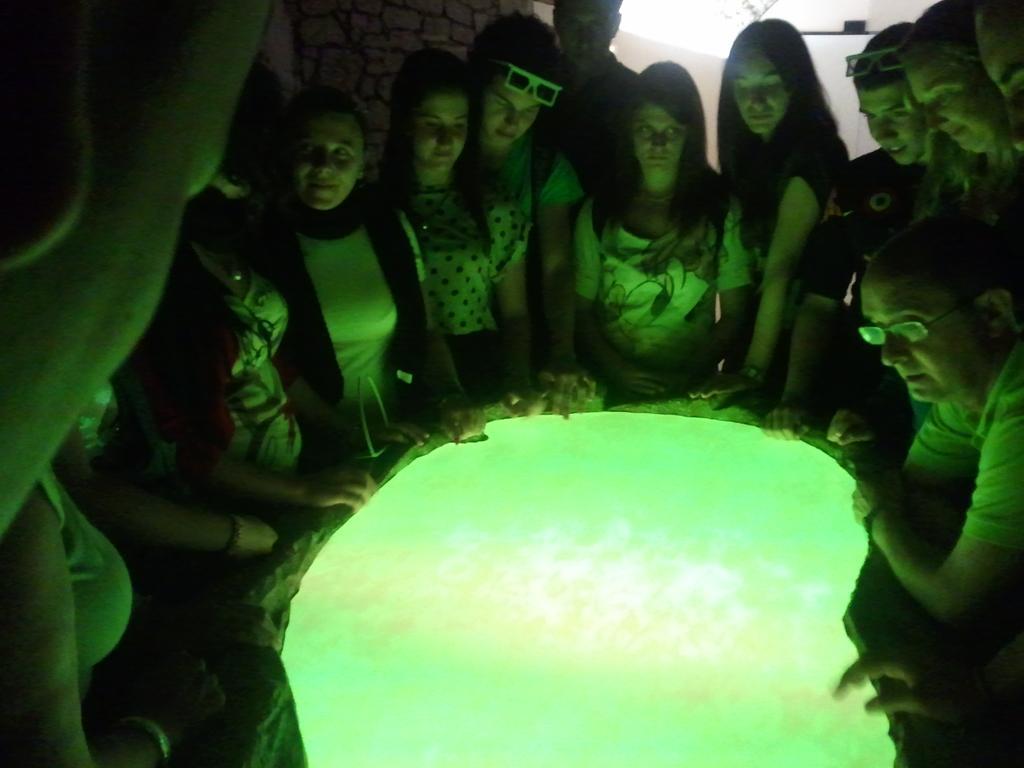Please provide a concise description of this image. In this picture I can observe green color lighting table. There are some people standing around this table. There are men and women in this picture. In the background there is white color light and a wall. 